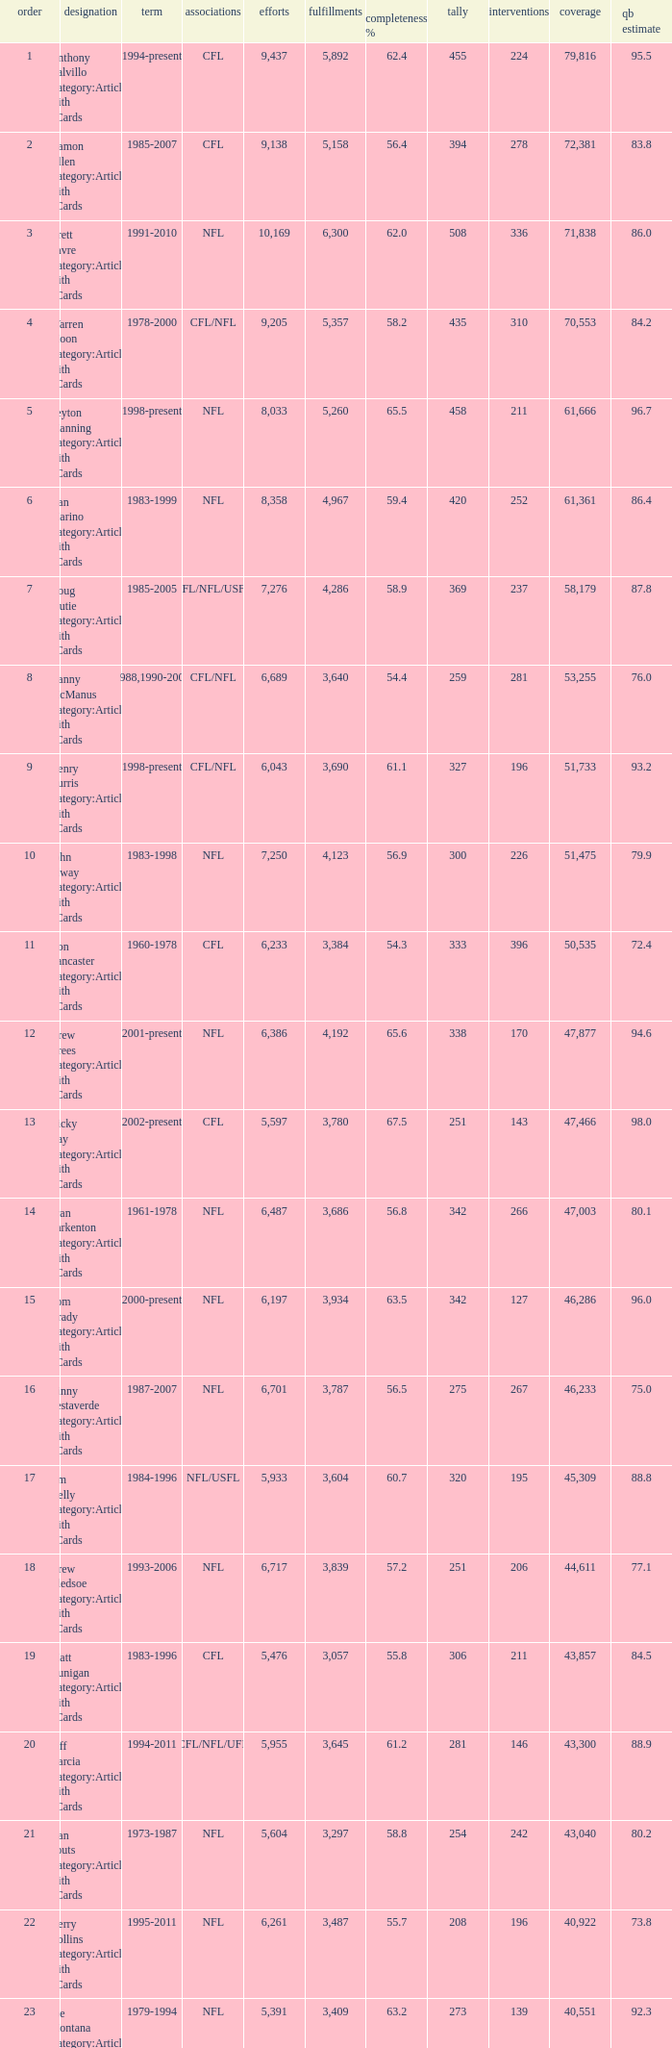What is the number of interceptions with less than 3,487 completions , more than 40,551 yardage, and the comp % is 55.8? 211.0. 